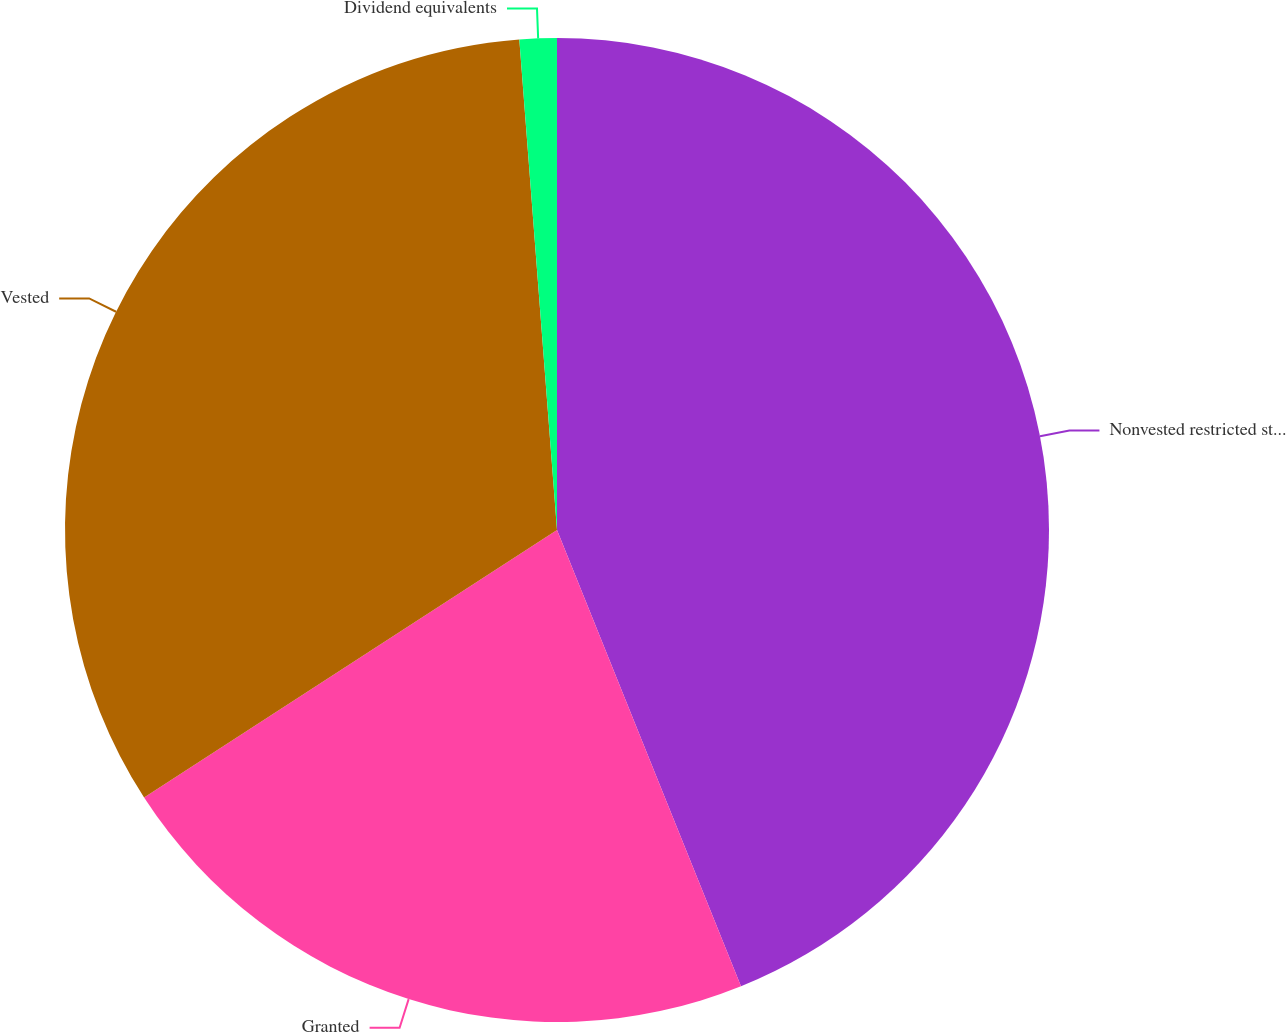Convert chart. <chart><loc_0><loc_0><loc_500><loc_500><pie_chart><fcel>Nonvested restricted stock at<fcel>Granted<fcel>Vested<fcel>Dividend equivalents<nl><fcel>43.9%<fcel>21.95%<fcel>32.93%<fcel>1.22%<nl></chart> 